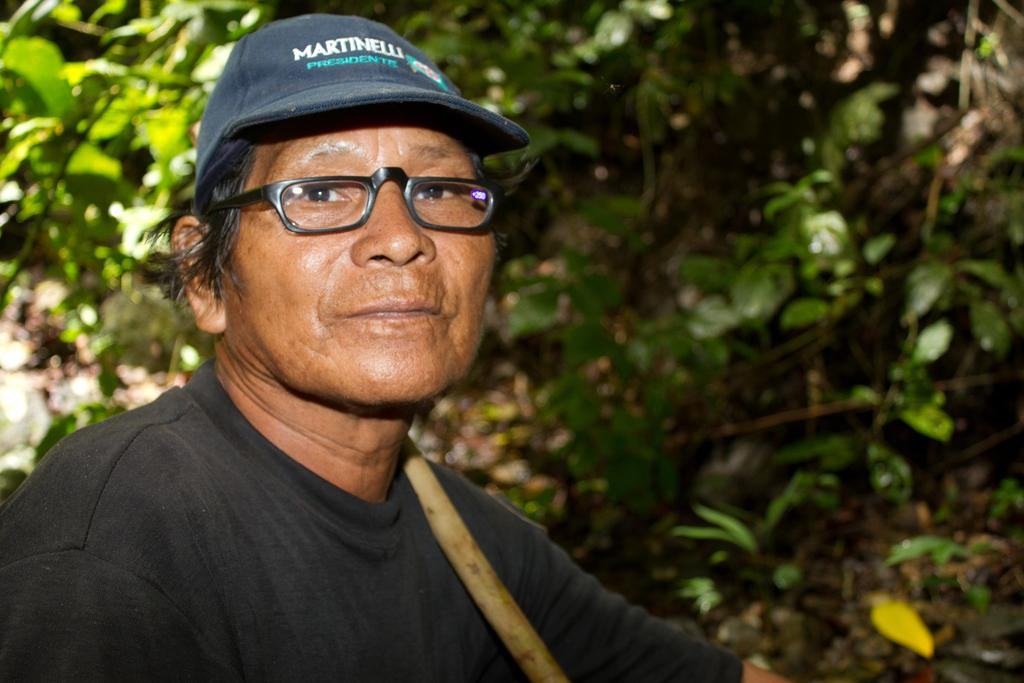Who or what is the main subject in the image? There is a person in the image. What is the person wearing on their head? The person is wearing a cap. What can be seen behind the person in the image? There is a group of plants behind the person. What flavor of nail polish is the person wearing in the image? There is no nail polish visible in the image, and therefore no flavor can be determined. 